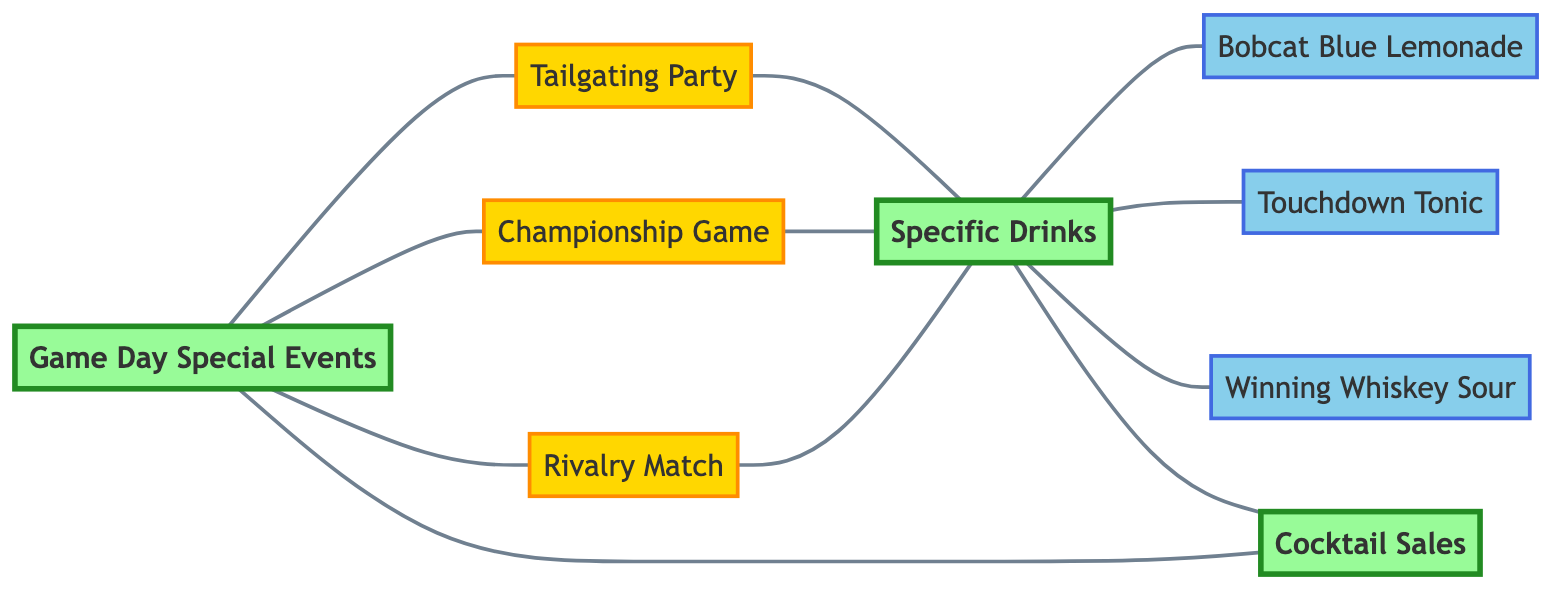What are the main nodes in the diagram? The main nodes in the diagram are "Game Day Special Events," "Cocktail Sales," and "Specific Drinks." These nodes represent the central concepts being analyzed in relation to cocktail sales.
Answer: Game Day Special Events, Cocktail Sales, Specific Drinks How many event nodes are present in the diagram? There are three event nodes: "Tailgating Party," "Championship Game," and "Rivalry Match." These nodes are connected to the main node and represent specific events that drive demand.
Answer: 3 What drinks are linked to the "Specific Drinks" node? The drinks linked to the "Specific Drinks" node are "Bobcat Blue Lemonade," "Touchdown Tonic," and "Winning Whiskey Sour." These drinks are specifically offered during the game day special events.
Answer: Bobcat Blue Lemonade, Touchdown Tonic, Winning Whiskey Sour What directly affects "Cocktail Sales" apart from "Specific Drinks"? "Game Day Special Events" directly affects "Cocktail Sales" as well, indicating that the type of event influences overall sales.
Answer: Game Day Special Events Which event leads to the highest demand for specific drinks according to the diagram? The diagram doesn't specify a single event leading to the highest demand; instead, all three events connect to "Specific Drinks," suggesting they all drive demand.
Answer: All three events How many total edges connect the nodes in the diagram? The diagram comprises ten edges, indicating the relationships between nodes. Each connection represents an interaction or impact one node has on another.
Answer: 10 What is the relationship between "Tailgating Party" and "Cocktail Sales"? "Tailgating Party" contributes indirectly to "Cocktail Sales" through its connection to "Specific Drinks," which then influences overall sales.
Answer: Indirect relationship Which drinks are expected to increase in sales during the "Championship Game"? The expected drinks to increase in sales during the "Championship Game" are all linked to the "Specific Drinks" node: "Bobcat Blue Lemonade," "Touchdown Tonic," and "Winning Whiskey Sour."
Answer: Bobcat Blue Lemonade, Touchdown Tonic, Winning Whiskey Sour What is the significance of the "Specific Drinks" node in terms of sales? The "Specific Drinks" node is crucial as it links multiple drinks to "Cocktail Sales," indicating that these drinks are likely responsible for driving sales during events.
Answer: Crucial for driving sales 